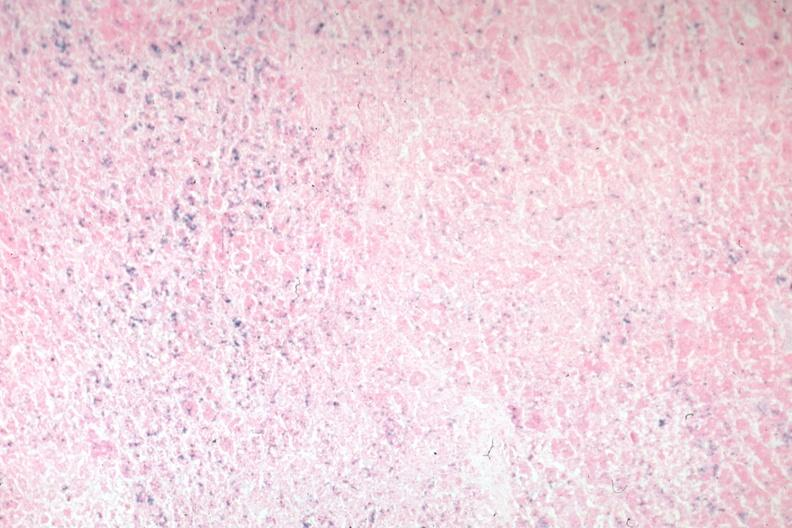does lymphoma show iron stain?
Answer the question using a single word or phrase. No 